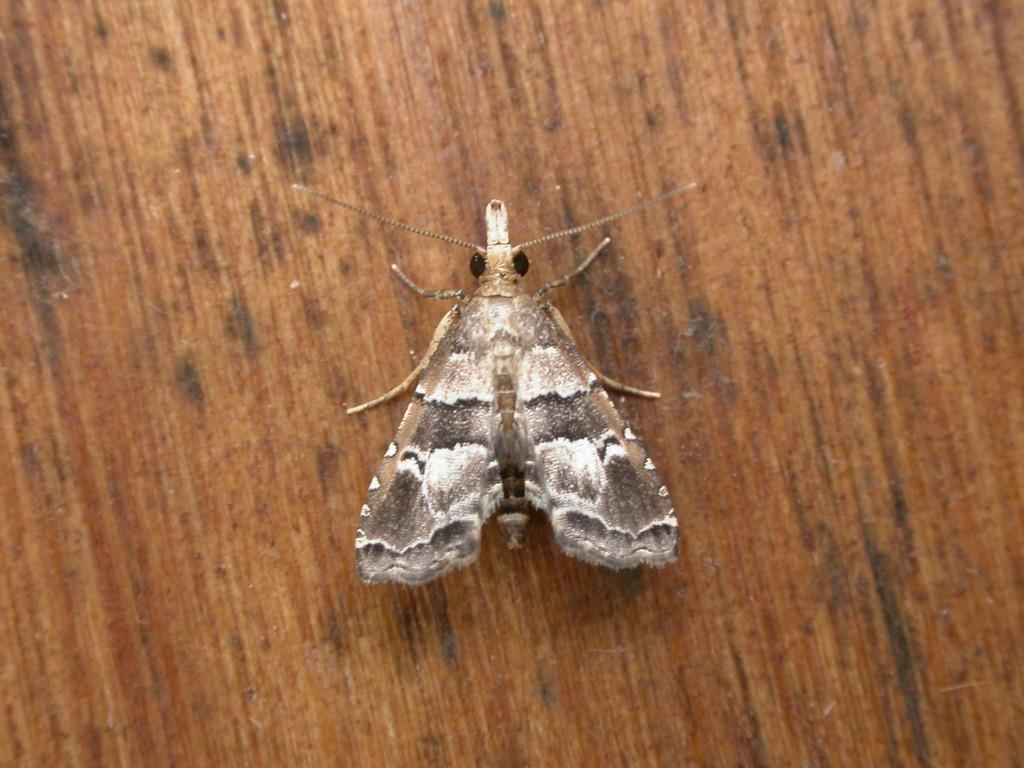How would you summarize this image in a sentence or two? In the center of the image we can see an insect on the wooden surface. 